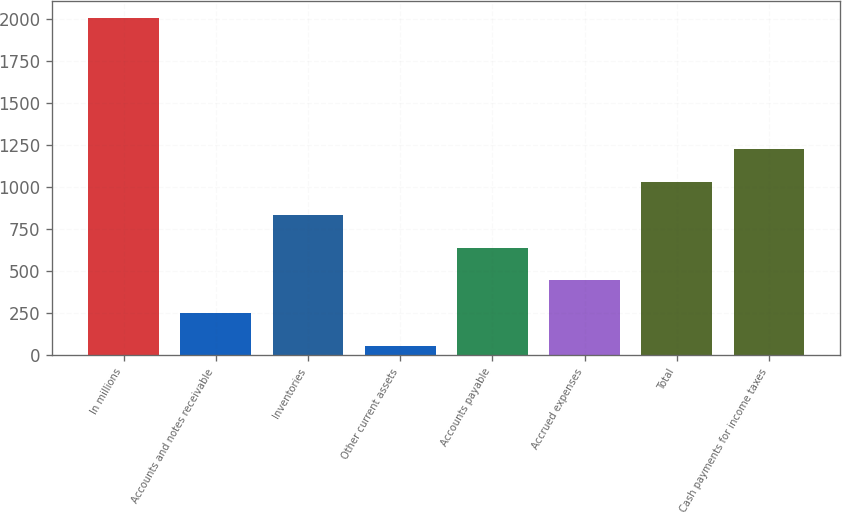<chart> <loc_0><loc_0><loc_500><loc_500><bar_chart><fcel>In millions<fcel>Accounts and notes receivable<fcel>Inventories<fcel>Other current assets<fcel>Accounts payable<fcel>Accrued expenses<fcel>Total<fcel>Cash payments for income taxes<nl><fcel>2008<fcel>249.4<fcel>835.6<fcel>54<fcel>640.2<fcel>444.8<fcel>1031<fcel>1226.4<nl></chart> 